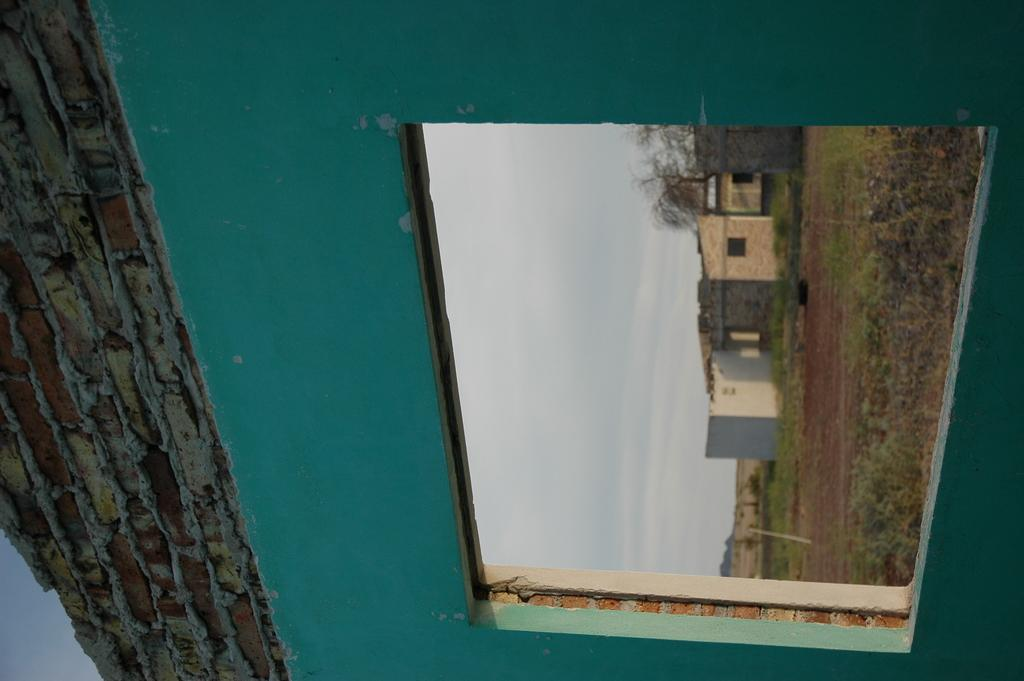What can be seen through the open window in the image? Grass, houses, plants, trees, and the sky are visible through the open window in the image. What is the condition of the wall in the image? There is a brick wall in the image. How is the window positioned in the image? The window is open in the image. What type of linen is draped over the houses in the image? There is no linen draped over the houses in the image; the houses are visible through the open window. Can you tell me how many visitors are present in the image? There is no indication of visitors in the image; it primarily features an open window with a view of the surrounding environment. 